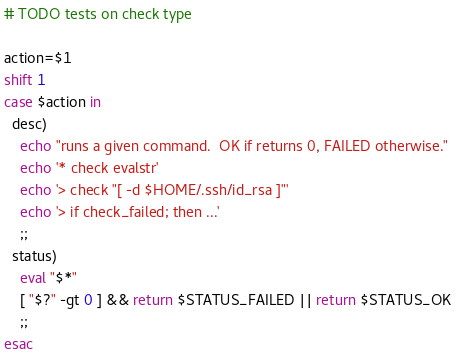<code> <loc_0><loc_0><loc_500><loc_500><_Bash_># TODO tests on check type

action=$1
shift 1
case $action in
  desc)
    echo "runs a given command.  OK if returns 0, FAILED otherwise."
    echo '* check evalstr'
    echo '> check "[ -d $HOME/.ssh/id_rsa ]"'
    echo '> if check_failed; then ...'
    ;;
  status)
    eval "$*"
    [ "$?" -gt 0 ] && return $STATUS_FAILED || return $STATUS_OK
    ;;
esac
</code> 